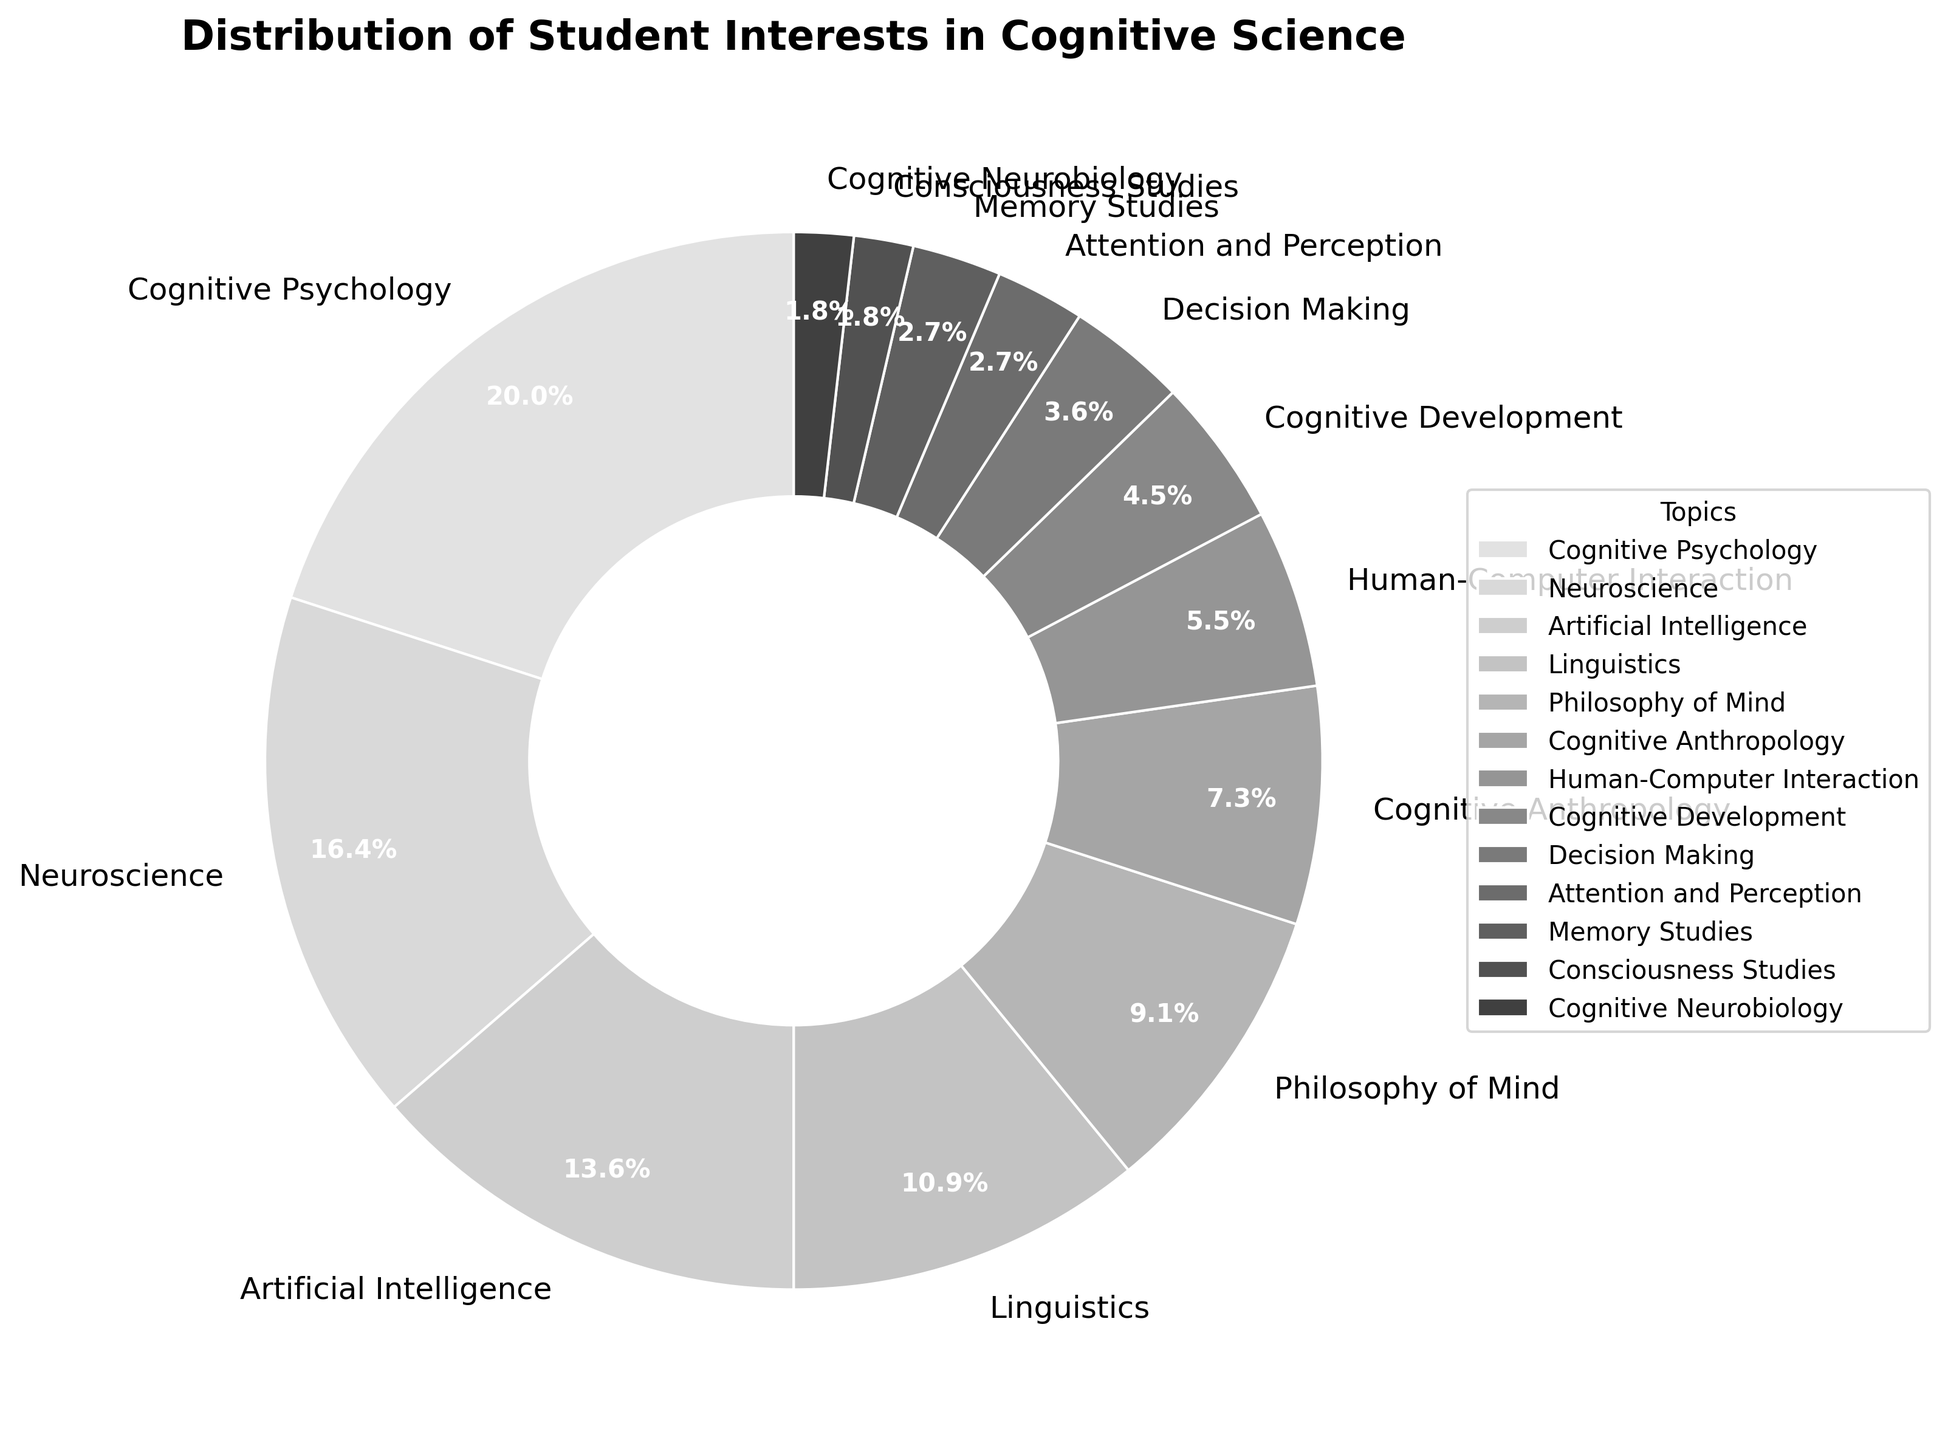What percentage of student interests is accounted for by Cognitive Psychology and Neuroscience combined? Cognitive Psychology accounts for 22% and Neuroscience accounts for 18%. Combining these percentages: 22% + 18% = 40%.
Answer: 40% Which topic has a higher percentage of student interest: Philosophy of Mind or Artificial Intelligence? Philosophy of Mind has a percentage of 10%, while Artificial Intelligence has 15%. Therefore, Artificial Intelligence has a higher percentage.
Answer: Artificial Intelligence What is the difference in percentage between Decision Making and Attention and Perception? Decision Making has 4% and Attention and Perception has 3%. The difference is 4% - 3% = 1%.
Answer: 1% How many topics have a percentage of student interest greater than 10%? The topics with percentages greater than 10% are Cognitive Psychology (22%), Neuroscience (18%), Artificial Intelligence (15%), Linguistics (12%). That's a total of 4 topics.
Answer: 4 What's the sum of the percentages of the three least popular topics? The three least popular topics are Consciousness Studies (2%), Cognitive Neurobiology (2%), and Memory Studies (3%). Summing these: 2% + 2% + 3% = 7%.
Answer: 7% Which topic has the smallest percentage of student interest? The smallest percentage is tied between Consciousness Studies and Cognitive Neurobiology, each with 2%.
Answer: Consciousness Studies, Cognitive Neurobiology Are there more topics with a percentage of student interest below 10% or above 10%? Below 10%, there are Cognitive Anthropology (8%), Human-Computer Interaction (6%), Cognitive Development (5%), Decision Making (4%), Attention and Perception (3%), Memory Studies (3%), Consciousness Studies (2%), Cognitive Neurobiology (2%), which sum to 8 topics. Above 10%, there are Cognitive Psychology (22%), Neuroscience (18%), Artificial Intelligence (15%), Linguistics (12%), Philosophy of Mind (10%), which sum to 5 topics. Therefore, there are more topics below 10%.
Answer: Below 10% By how much does the percentage of interest in Cognitive Anthropology exceed that in Cognitive Development? Cognitive Anthropology is at 8% and Cognitive Development is at 5%, so the difference is 8% - 5% = 3%.
Answer: 3% 